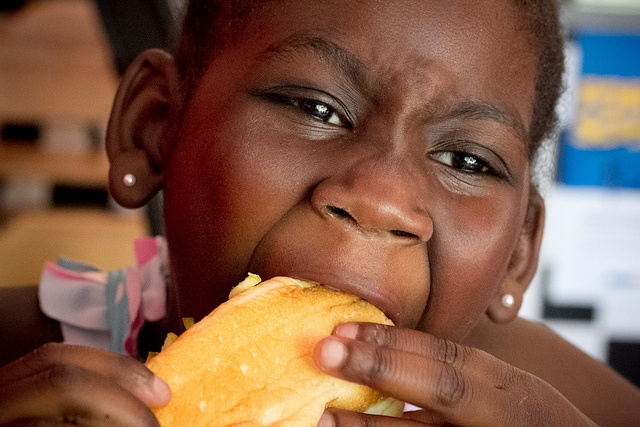Describe the objects in this image and their specific colors. I can see people in black, maroon, and brown tones, sandwich in black, gold, orange, and khaki tones, and hot dog in black, gold, orange, and khaki tones in this image. 